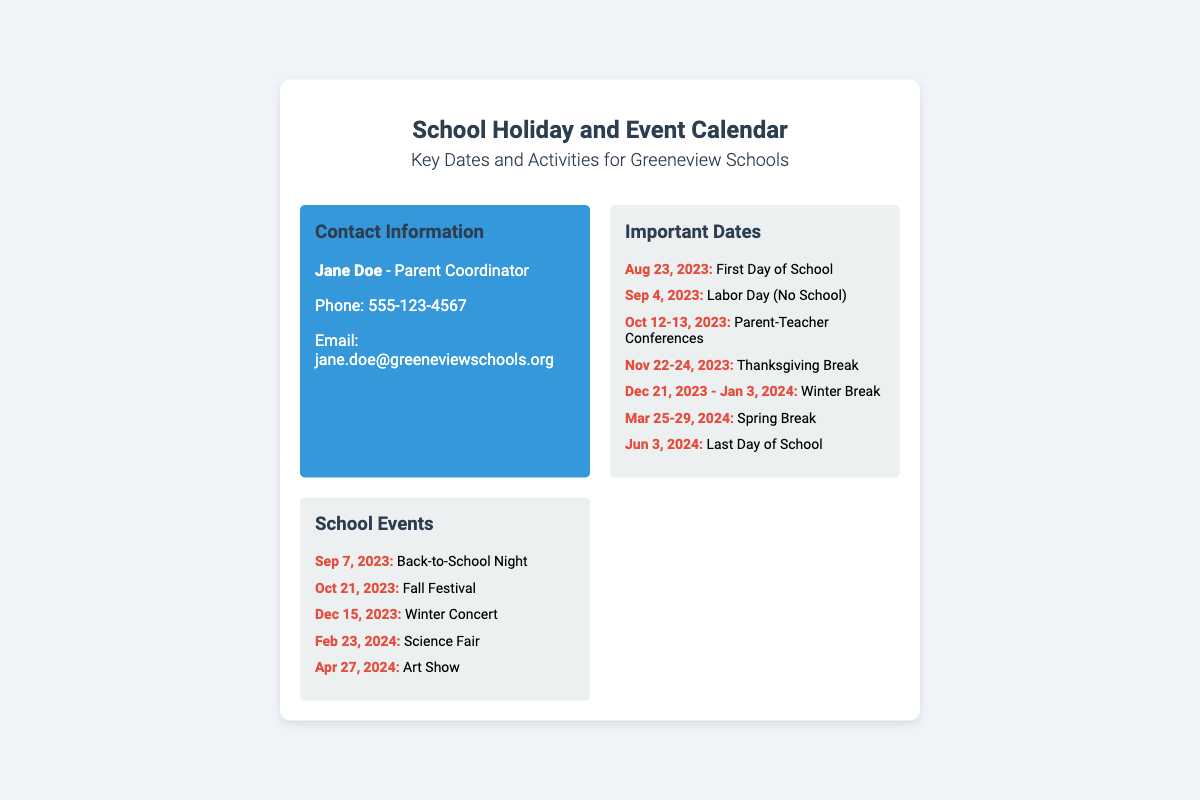What is the date of the first day of school? The first day of school is specified in the "Important Dates" section of the document.
Answer: Aug 23, 2023 When is Labor Day? Labor Day is listed in the "Important Dates" section of the document.
Answer: Sep 4, 2023 How long is the Winter Break? The duration of the Winter Break can be gathered from the "Important Dates" section of the document.
Answer: Dec 21, 2023 - Jan 3, 2024 What event occurs on Dec 15, 2023? The event on Dec 15, 2023, is mentioned in the "School Events" section of the document.
Answer: Winter Concert Name one school event in February 2024. The "School Events" section lists events by month, including February.
Answer: Science Fair Who is the Parent Coordinator? The name of the Parent Coordinator is provided in the "Contact Information" section.
Answer: Jane Doe How many important dates are listed? The number of items in the "Important Dates" section can be counted from the document.
Answer: 7 What is the last day of school? The last day of school is detailed in the "Important Dates" section of the document.
Answer: Jun 3, 2024 What is the background color of the contact information section? The document specifies the styling of various sections, including the contact information background color.
Answer: #3498db 